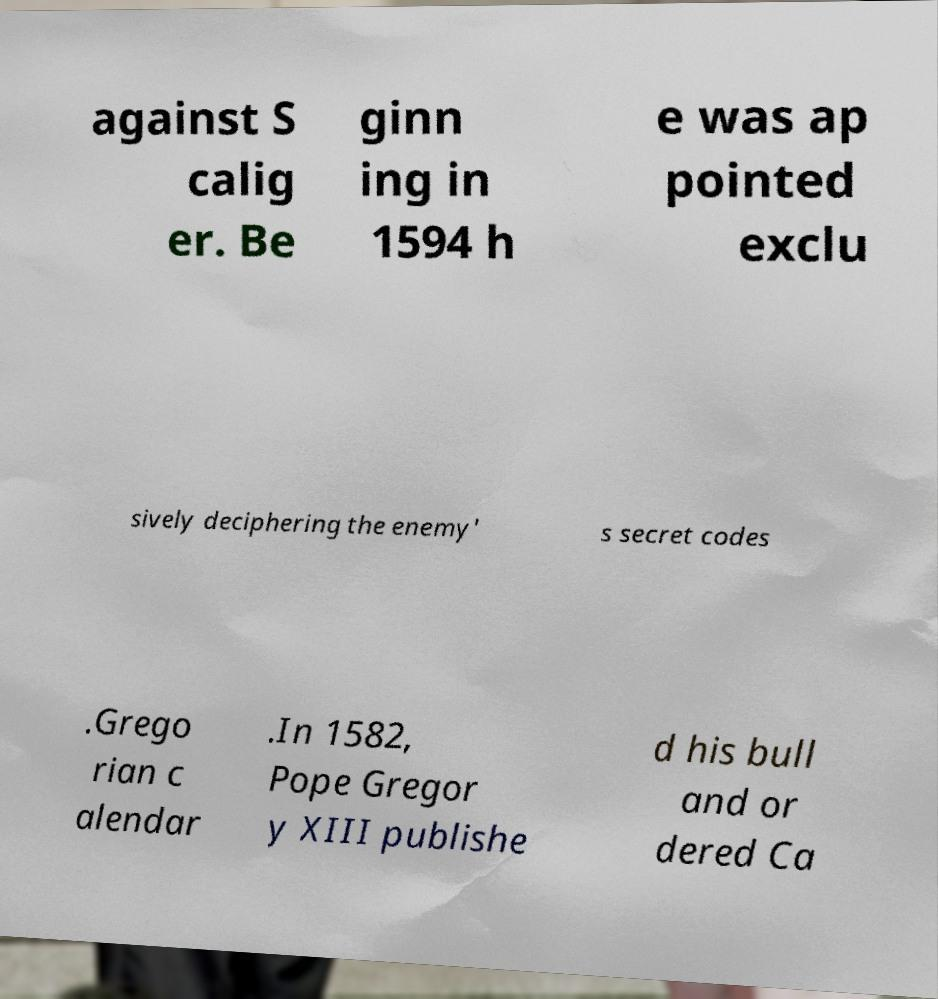Can you read and provide the text displayed in the image?This photo seems to have some interesting text. Can you extract and type it out for me? against S calig er. Be ginn ing in 1594 h e was ap pointed exclu sively deciphering the enemy' s secret codes .Grego rian c alendar .In 1582, Pope Gregor y XIII publishe d his bull and or dered Ca 